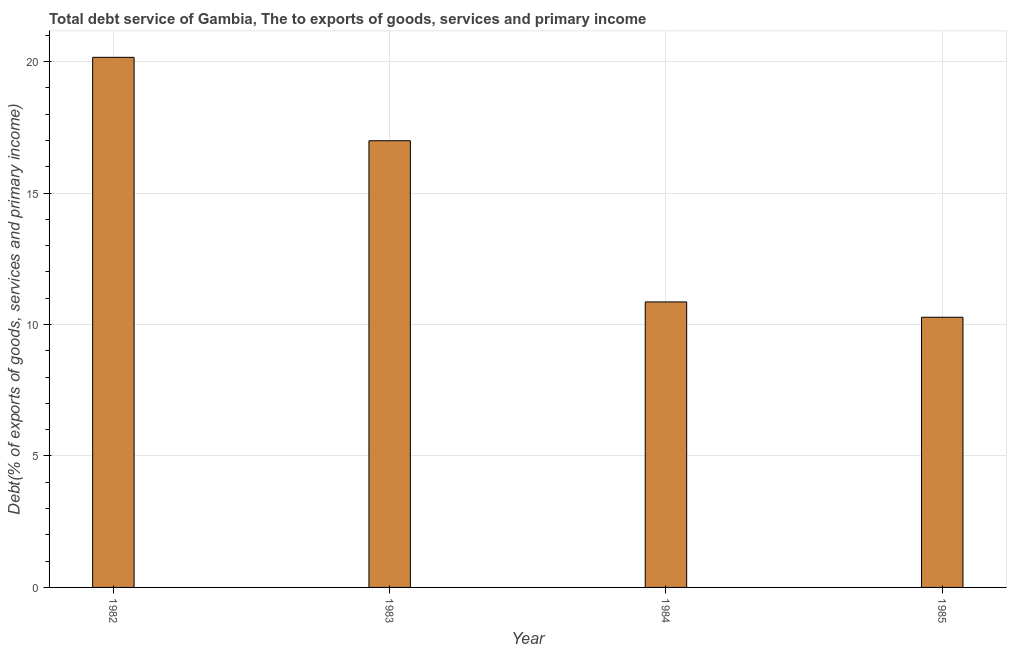Does the graph contain any zero values?
Your answer should be compact. No. Does the graph contain grids?
Offer a very short reply. Yes. What is the title of the graph?
Offer a terse response. Total debt service of Gambia, The to exports of goods, services and primary income. What is the label or title of the Y-axis?
Your answer should be very brief. Debt(% of exports of goods, services and primary income). What is the total debt service in 1984?
Your answer should be very brief. 10.86. Across all years, what is the maximum total debt service?
Make the answer very short. 20.16. Across all years, what is the minimum total debt service?
Make the answer very short. 10.28. What is the sum of the total debt service?
Ensure brevity in your answer.  58.29. What is the difference between the total debt service in 1982 and 1984?
Your response must be concise. 9.3. What is the average total debt service per year?
Offer a very short reply. 14.57. What is the median total debt service?
Ensure brevity in your answer.  13.92. In how many years, is the total debt service greater than 15 %?
Offer a very short reply. 2. What is the ratio of the total debt service in 1983 to that in 1984?
Your answer should be very brief. 1.56. Is the difference between the total debt service in 1982 and 1984 greater than the difference between any two years?
Keep it short and to the point. No. What is the difference between the highest and the second highest total debt service?
Your answer should be compact. 3.17. Is the sum of the total debt service in 1982 and 1985 greater than the maximum total debt service across all years?
Give a very brief answer. Yes. What is the difference between the highest and the lowest total debt service?
Ensure brevity in your answer.  9.89. In how many years, is the total debt service greater than the average total debt service taken over all years?
Make the answer very short. 2. How many bars are there?
Your answer should be very brief. 4. Are all the bars in the graph horizontal?
Keep it short and to the point. No. What is the Debt(% of exports of goods, services and primary income) in 1982?
Make the answer very short. 20.16. What is the Debt(% of exports of goods, services and primary income) in 1983?
Provide a short and direct response. 16.99. What is the Debt(% of exports of goods, services and primary income) in 1984?
Keep it short and to the point. 10.86. What is the Debt(% of exports of goods, services and primary income) in 1985?
Offer a very short reply. 10.28. What is the difference between the Debt(% of exports of goods, services and primary income) in 1982 and 1983?
Your answer should be very brief. 3.17. What is the difference between the Debt(% of exports of goods, services and primary income) in 1982 and 1984?
Offer a terse response. 9.3. What is the difference between the Debt(% of exports of goods, services and primary income) in 1982 and 1985?
Make the answer very short. 9.89. What is the difference between the Debt(% of exports of goods, services and primary income) in 1983 and 1984?
Your answer should be compact. 6.13. What is the difference between the Debt(% of exports of goods, services and primary income) in 1983 and 1985?
Give a very brief answer. 6.71. What is the difference between the Debt(% of exports of goods, services and primary income) in 1984 and 1985?
Offer a terse response. 0.58. What is the ratio of the Debt(% of exports of goods, services and primary income) in 1982 to that in 1983?
Your answer should be compact. 1.19. What is the ratio of the Debt(% of exports of goods, services and primary income) in 1982 to that in 1984?
Provide a succinct answer. 1.86. What is the ratio of the Debt(% of exports of goods, services and primary income) in 1982 to that in 1985?
Your answer should be very brief. 1.96. What is the ratio of the Debt(% of exports of goods, services and primary income) in 1983 to that in 1984?
Offer a very short reply. 1.56. What is the ratio of the Debt(% of exports of goods, services and primary income) in 1983 to that in 1985?
Ensure brevity in your answer.  1.65. What is the ratio of the Debt(% of exports of goods, services and primary income) in 1984 to that in 1985?
Your answer should be compact. 1.06. 